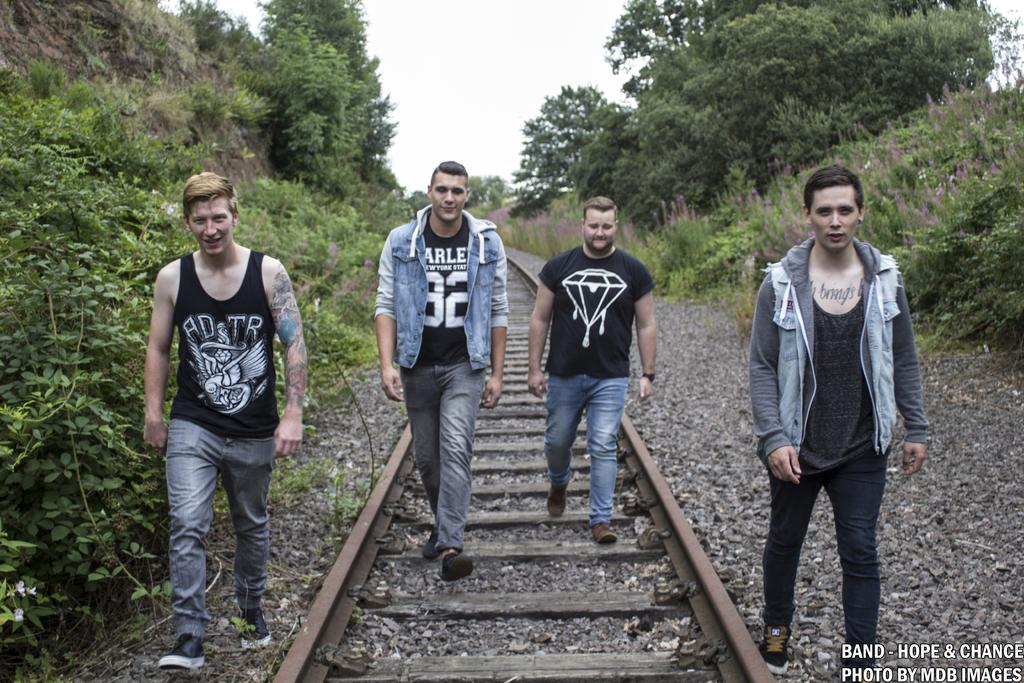How many people are in the image? There are four men in the image. What are the men doing in the image? The men are walking on tracks and stones. Is there any text present in the image? Yes, there is text at the bottom of the image. What can be seen in the background of the image? There are plants and trees in the background of the image. What type of wool is being used by the parent in the image? There is no wool or parent present in the image; it features four men walking on tracks and stones. 